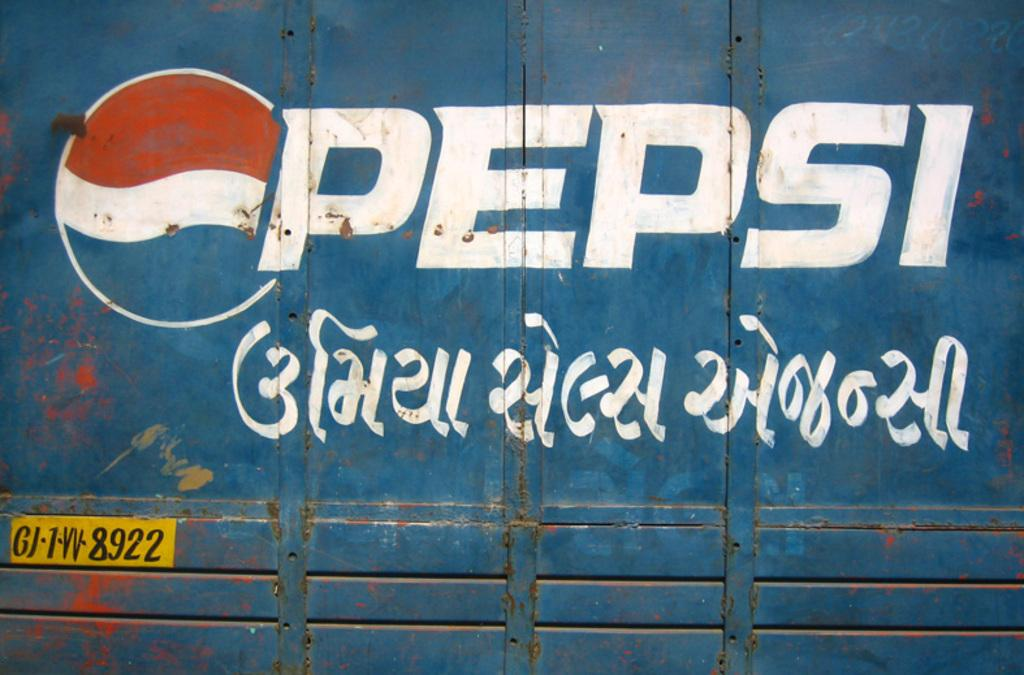<image>
Write a terse but informative summary of the picture. A large blue metal container says Pepsi on the side. 